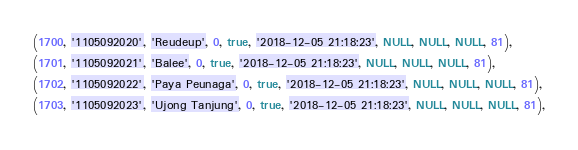<code> <loc_0><loc_0><loc_500><loc_500><_SQL_>(1700, '1105092020', 'Reudeup', 0, true, '2018-12-05 21:18:23', NULL, NULL, NULL, 81),
(1701, '1105092021', 'Balee', 0, true, '2018-12-05 21:18:23', NULL, NULL, NULL, 81),
(1702, '1105092022', 'Paya Peunaga', 0, true, '2018-12-05 21:18:23', NULL, NULL, NULL, 81),
(1703, '1105092023', 'Ujong Tanjung', 0, true, '2018-12-05 21:18:23', NULL, NULL, NULL, 81),</code> 